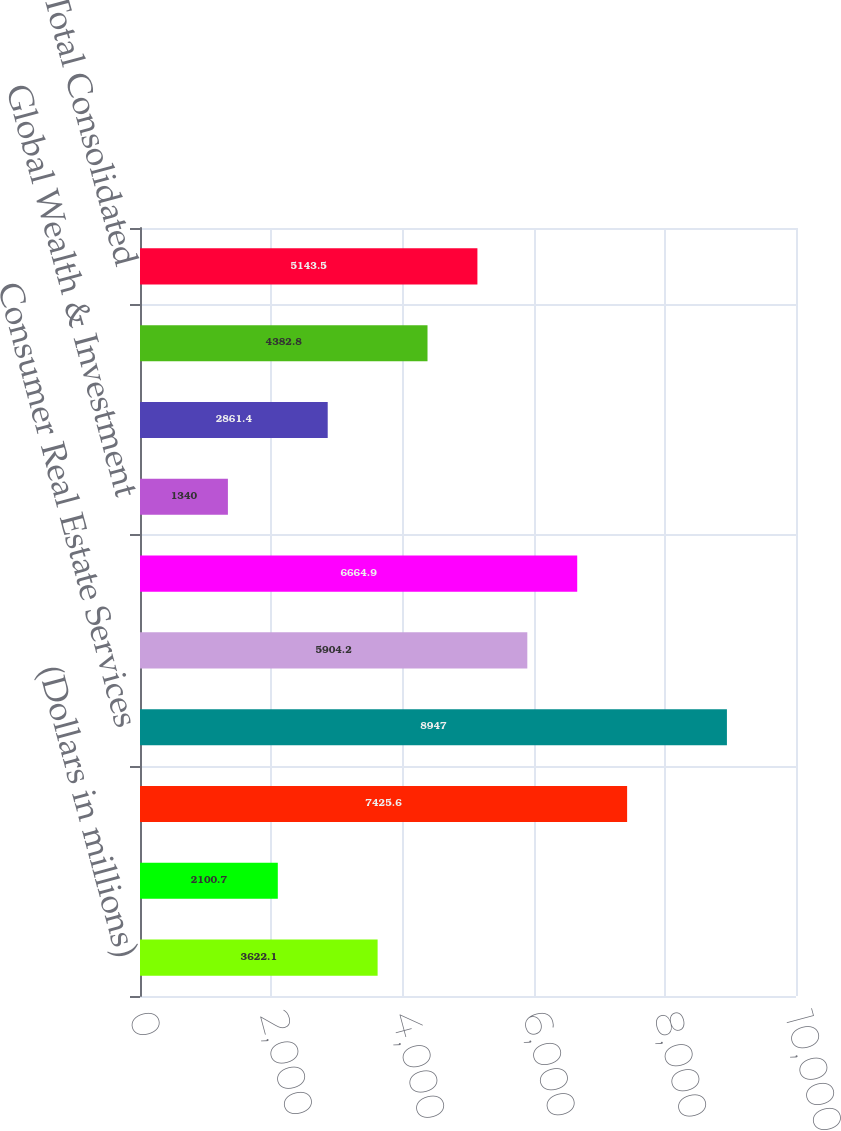Convert chart. <chart><loc_0><loc_0><loc_500><loc_500><bar_chart><fcel>(Dollars in millions)<fcel>Deposits<fcel>Card Services<fcel>Consumer Real Estate Services<fcel>Global Commercial Banking<fcel>Global Banking & Markets<fcel>Global Wealth & Investment<fcel>All Other<fcel>Total FTE basis<fcel>Total Consolidated<nl><fcel>3622.1<fcel>2100.7<fcel>7425.6<fcel>8947<fcel>5904.2<fcel>6664.9<fcel>1340<fcel>2861.4<fcel>4382.8<fcel>5143.5<nl></chart> 